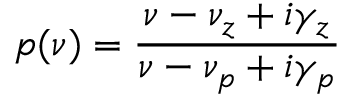<formula> <loc_0><loc_0><loc_500><loc_500>p ( \nu ) = \frac { \nu - \nu _ { z } + i \gamma _ { z } } { \nu - \nu _ { p } + i \gamma _ { p } }</formula> 